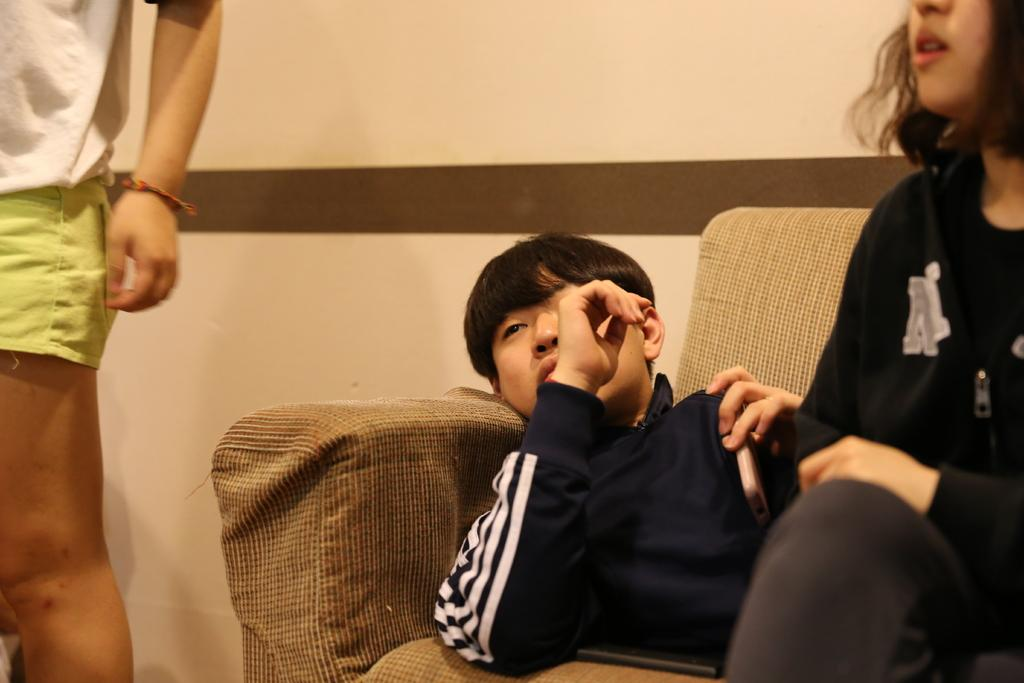What is the man doing in the image? The man is lying on the sofa in the image. What is the woman doing in the image? The woman is sitting on the sofa in the image. What is the woman wearing in the image? The woman is wearing a black dress in the image. What can be seen behind the sofa in the image? There is a wall visible in the image. Can you describe the fairies flying around the room in the image? There are no fairies present in the image; it only shows a man lying on the sofa and a woman sitting on the sofa. 